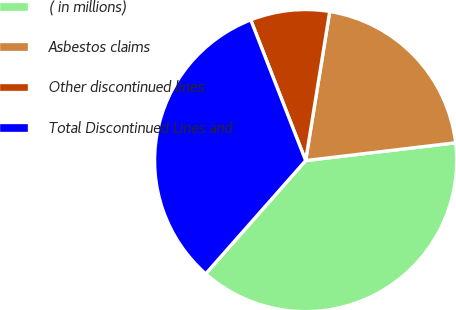Convert chart to OTSL. <chart><loc_0><loc_0><loc_500><loc_500><pie_chart><fcel>( in millions)<fcel>Asbestos claims<fcel>Other discontinued lines<fcel>Total Discontinued Lines and<nl><fcel>38.39%<fcel>20.57%<fcel>8.47%<fcel>32.57%<nl></chart> 